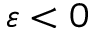Convert formula to latex. <formula><loc_0><loc_0><loc_500><loc_500>\varepsilon < 0</formula> 